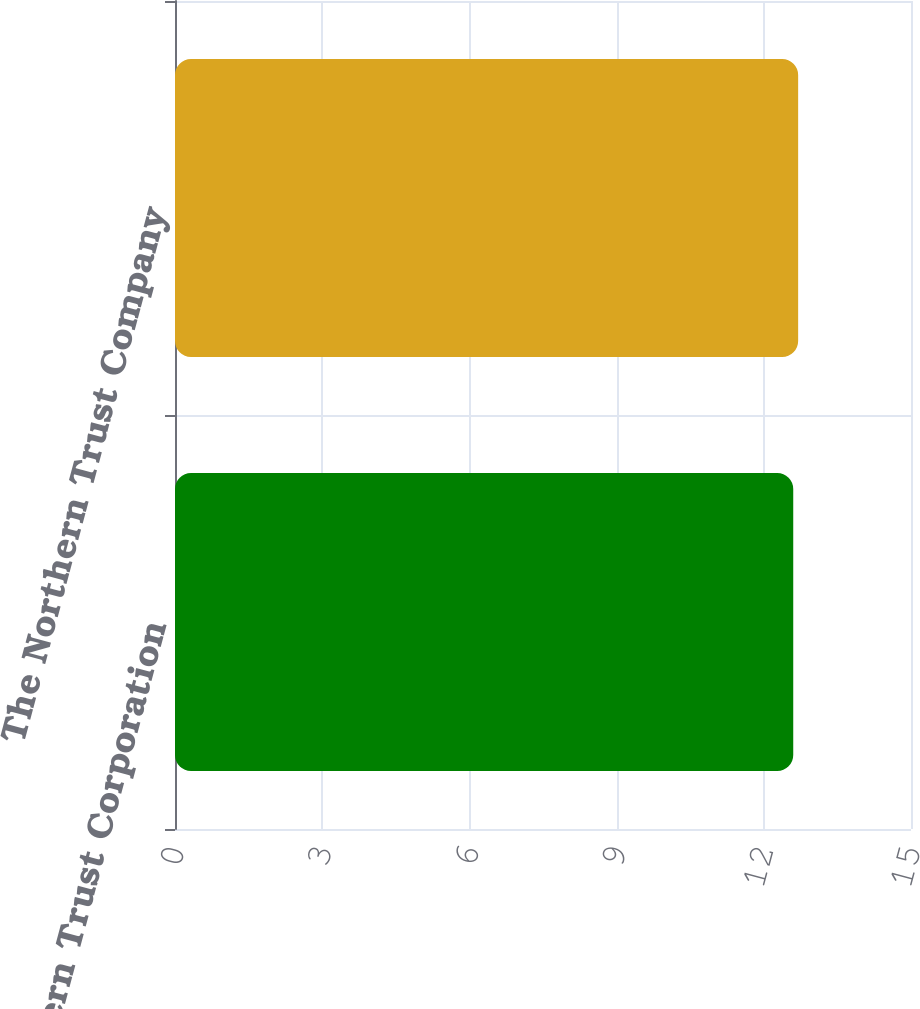Convert chart. <chart><loc_0><loc_0><loc_500><loc_500><bar_chart><fcel>Northern Trust Corporation<fcel>The Northern Trust Company<nl><fcel>12.6<fcel>12.7<nl></chart> 